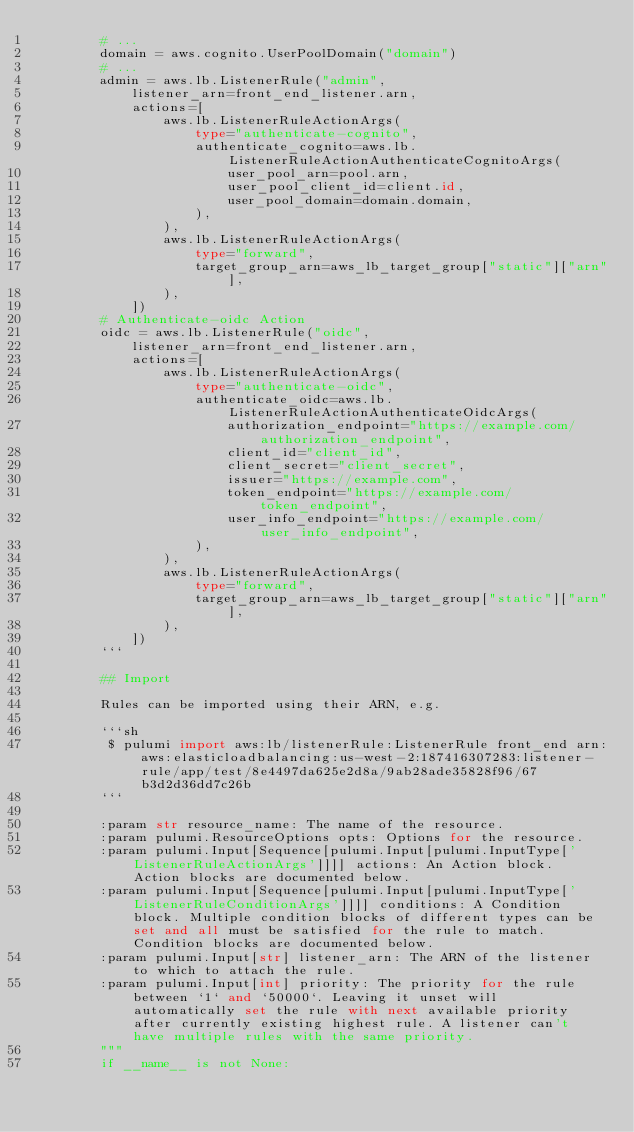<code> <loc_0><loc_0><loc_500><loc_500><_Python_>        # ...
        domain = aws.cognito.UserPoolDomain("domain")
        # ...
        admin = aws.lb.ListenerRule("admin",
            listener_arn=front_end_listener.arn,
            actions=[
                aws.lb.ListenerRuleActionArgs(
                    type="authenticate-cognito",
                    authenticate_cognito=aws.lb.ListenerRuleActionAuthenticateCognitoArgs(
                        user_pool_arn=pool.arn,
                        user_pool_client_id=client.id,
                        user_pool_domain=domain.domain,
                    ),
                ),
                aws.lb.ListenerRuleActionArgs(
                    type="forward",
                    target_group_arn=aws_lb_target_group["static"]["arn"],
                ),
            ])
        # Authenticate-oidc Action
        oidc = aws.lb.ListenerRule("oidc",
            listener_arn=front_end_listener.arn,
            actions=[
                aws.lb.ListenerRuleActionArgs(
                    type="authenticate-oidc",
                    authenticate_oidc=aws.lb.ListenerRuleActionAuthenticateOidcArgs(
                        authorization_endpoint="https://example.com/authorization_endpoint",
                        client_id="client_id",
                        client_secret="client_secret",
                        issuer="https://example.com",
                        token_endpoint="https://example.com/token_endpoint",
                        user_info_endpoint="https://example.com/user_info_endpoint",
                    ),
                ),
                aws.lb.ListenerRuleActionArgs(
                    type="forward",
                    target_group_arn=aws_lb_target_group["static"]["arn"],
                ),
            ])
        ```

        ## Import

        Rules can be imported using their ARN, e.g.

        ```sh
         $ pulumi import aws:lb/listenerRule:ListenerRule front_end arn:aws:elasticloadbalancing:us-west-2:187416307283:listener-rule/app/test/8e4497da625e2d8a/9ab28ade35828f96/67b3d2d36dd7c26b
        ```

        :param str resource_name: The name of the resource.
        :param pulumi.ResourceOptions opts: Options for the resource.
        :param pulumi.Input[Sequence[pulumi.Input[pulumi.InputType['ListenerRuleActionArgs']]]] actions: An Action block. Action blocks are documented below.
        :param pulumi.Input[Sequence[pulumi.Input[pulumi.InputType['ListenerRuleConditionArgs']]]] conditions: A Condition block. Multiple condition blocks of different types can be set and all must be satisfied for the rule to match. Condition blocks are documented below.
        :param pulumi.Input[str] listener_arn: The ARN of the listener to which to attach the rule.
        :param pulumi.Input[int] priority: The priority for the rule between `1` and `50000`. Leaving it unset will automatically set the rule with next available priority after currently existing highest rule. A listener can't have multiple rules with the same priority.
        """
        if __name__ is not None:</code> 